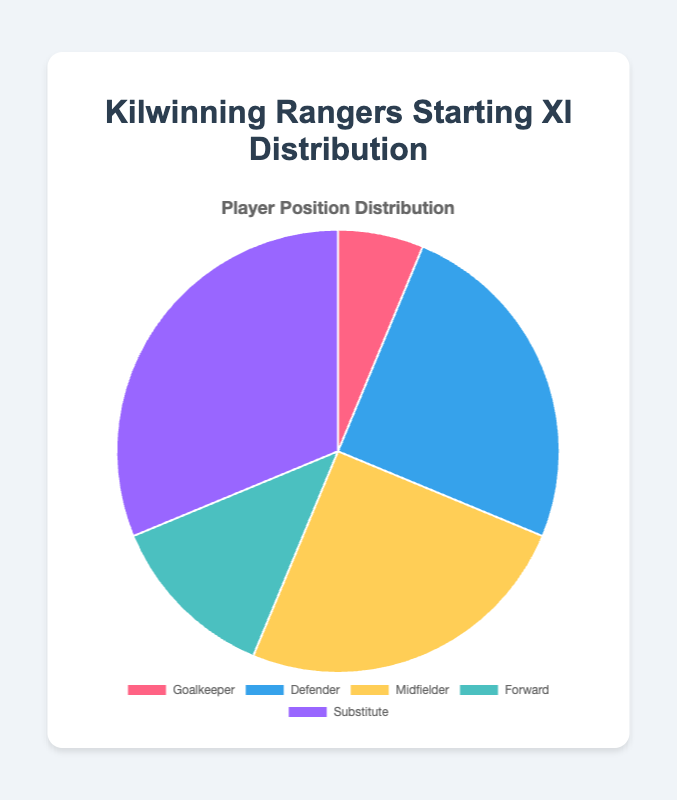How many midfielders are in the starting XI? From the pie chart, we can see the segment labeled "Midfielder" with 4 players.
Answer: 4 What is the total number of players (excluding substitutes) in the starting XI? The total number of players excluding substitutes can be found by summing the counts for Goalkeeper, Defender, Midfielder, and Forward: 1 + 4 + 4 + 2 = 11.
Answer: 11 Which player position has the highest representation? By visually inspecting the pie chart, "Substitute" has the largest segment with 5 players.
Answer: Substitute How many more forwards are there compared to goalkeepers? The pie chart shows 2 forwards and 1 goalkeeper. The difference is 2 - 1 = 1.
Answer: 1 What is the ratio of defenders to forwards? From the pie chart, there are 4 defenders and 2 forwards. The ratio is 4:2, which simplifies to 2:1.
Answer: 2:1 Which segment on the pie chart is colored blue? The segment representing "Defender" is colored blue.
Answer: Defender What percentage of the starting XI are substitutes? There are a total of 16 players (1 Goalkeeper + 4 Defenders + 4 Midfielders + 2 Forwards + 5 Substitutes). The percentage of substitutes is (5 / 16) * 100 ≈ 31.25%.
Answer: 31.25% Are there more midfielders or defenders in the starting XI? The pie chart shows that midfielders and defenders are equal in number with 4 players each.
Answer: Equal If you combine the number of goalkeepers and forwards, how many players do you get? There is 1 goalkeeper and 2 forwards. Combining them gives 1 + 2 = 3 players.
Answer: 3 Between defenders and midfielders, which position has a greater representation, and by how much? Both defenders and midfielders have the same representation; thus, there is no difference.
Answer: No difference 